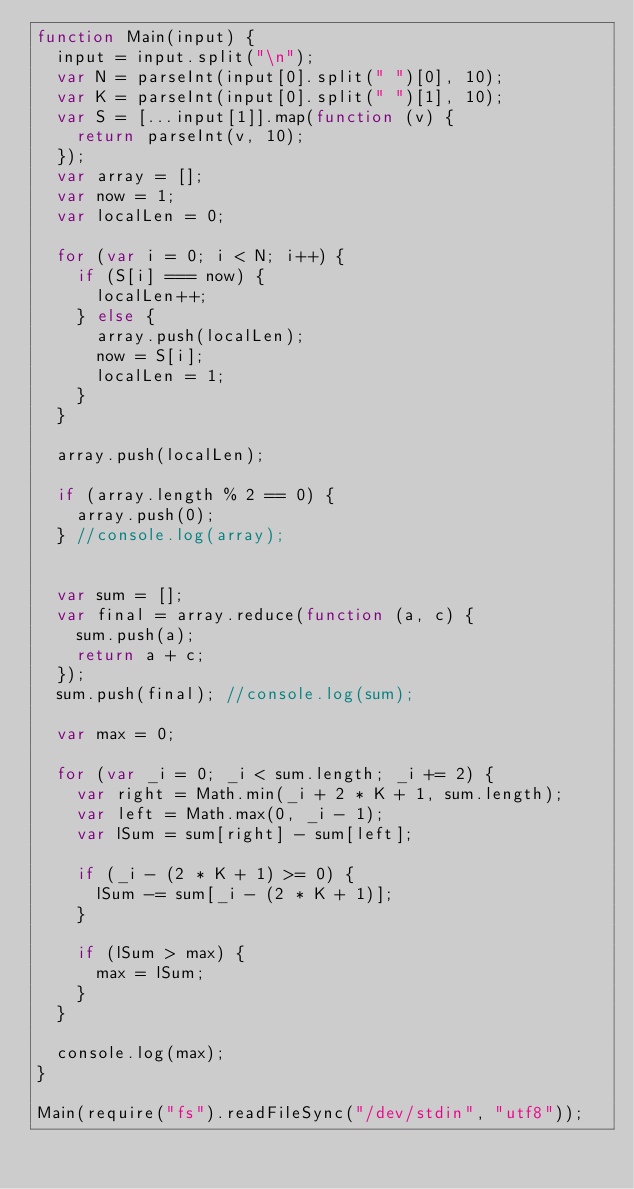<code> <loc_0><loc_0><loc_500><loc_500><_JavaScript_>function Main(input) {
  input = input.split("\n");
  var N = parseInt(input[0].split(" ")[0], 10);
  var K = parseInt(input[0].split(" ")[1], 10);
  var S = [...input[1]].map(function (v) {
    return parseInt(v, 10);
  });
  var array = [];
  var now = 1;
  var localLen = 0;

  for (var i = 0; i < N; i++) {
    if (S[i] === now) {
      localLen++;
    } else {
      array.push(localLen);
      now = S[i];
      localLen = 1;
    }
  }

  array.push(localLen);

  if (array.length % 2 == 0) {
    array.push(0);
  } //console.log(array);


  var sum = [];
  var final = array.reduce(function (a, c) {
    sum.push(a);
    return a + c;
  });
  sum.push(final); //console.log(sum);

  var max = 0;

  for (var _i = 0; _i < sum.length; _i += 2) {
    var right = Math.min(_i + 2 * K + 1, sum.length);
    var left = Math.max(0, _i - 1);
    var lSum = sum[right] - sum[left];

    if (_i - (2 * K + 1) >= 0) {
      lSum -= sum[_i - (2 * K + 1)];
    }

    if (lSum > max) {
      max = lSum;
    }
  }

  console.log(max);
}

Main(require("fs").readFileSync("/dev/stdin", "utf8"));</code> 